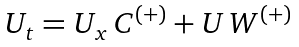Convert formula to latex. <formula><loc_0><loc_0><loc_500><loc_500>\begin{array} { l } U _ { t } = U _ { x } \, C ^ { ( + ) } + U \, W ^ { ( + ) } \, \end{array}</formula> 